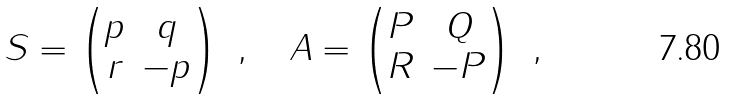<formula> <loc_0><loc_0><loc_500><loc_500>S = \begin{pmatrix} p & q \\ r & - p \end{pmatrix} \ , \quad A = \begin{pmatrix} P & Q \\ R & - P \end{pmatrix} \ ,</formula> 